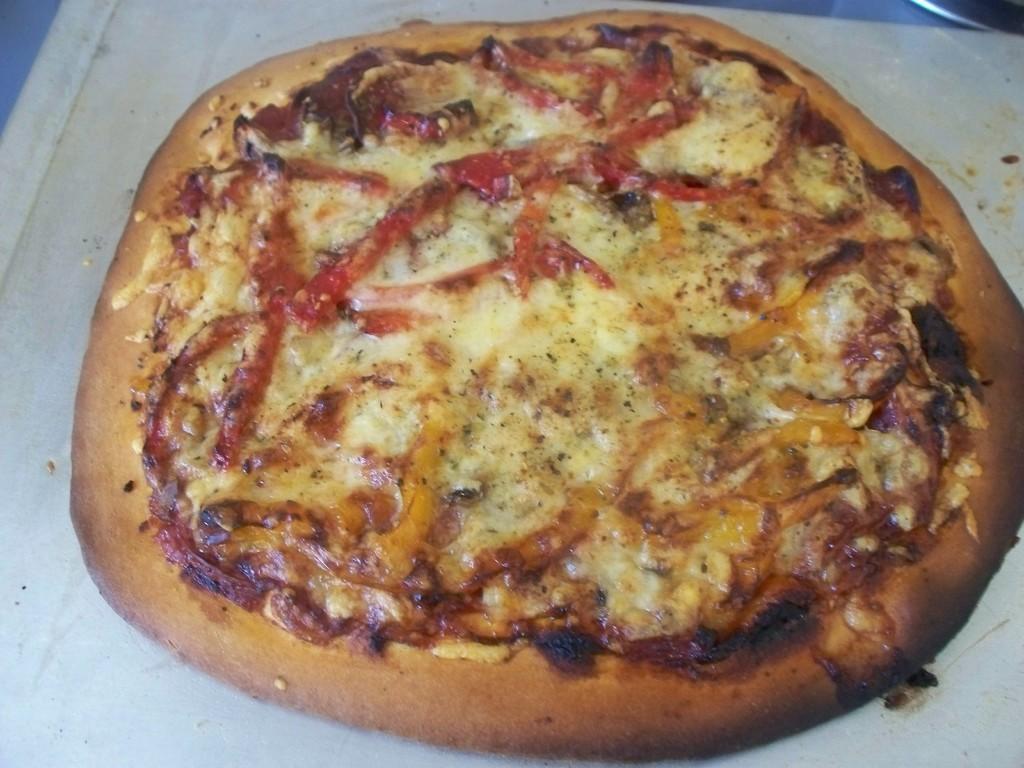Please provide a concise description of this image. In this image we can see pizza places on the table. 